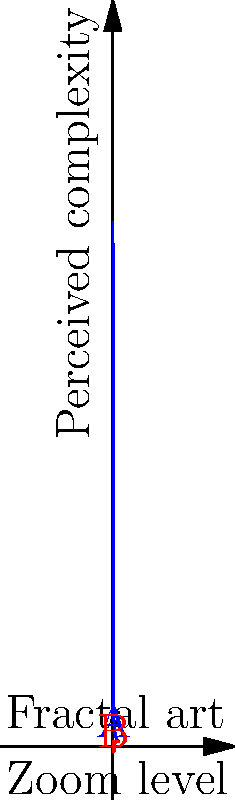Consider the graph representing the perceived complexity of fractal art at varying zoom levels. Line A (blue) shows a simple inverse relationship, while line B (red) demonstrates a more complex, oscillating pattern. Which line better represents the likely perception of fractal art complexity as zoom level increases, and why? To answer this question, let's consider the nature of fractal art and human perception:

1. Fractal art is characterized by self-similarity at different scales.
2. As we zoom in on a fractal, we typically reveal more intricate details.
3. Human perception of complexity is not always linear.

Step-by-step analysis:
1. Line A (blue) shows a simple inverse relationship between zoom level and perceived complexity. This suggests that as we zoom in (moving left on the x-axis), the perceived complexity increases uniformly.
2. Line B (red) shows an oscillating pattern, where perceived complexity fluctuates as zoom level changes.
3. In fractal art:
   a. Zooming in often reveals new details that were not visible at higher levels.
   b. These new details can cause sudden increases in perceived complexity.
   c. As one becomes accustomed to a certain level of detail, perceived complexity might temporarily decrease.
   d. Further zooming continues this cycle of revealing new complexities.
4. The oscillating pattern of Line B better captures this cyclical nature of perceiving fractal art complexity.
5. Line B also aligns with the concept of "cognitive load" in psychology, where perception of complexity can vary based on familiarity and the introduction of new information.

Therefore, Line B (red) better represents the likely perception of fractal art complexity as zoom level increases.
Answer: Line B (red), due to its oscillating pattern reflecting the cyclical nature of fractal complexity perception. 